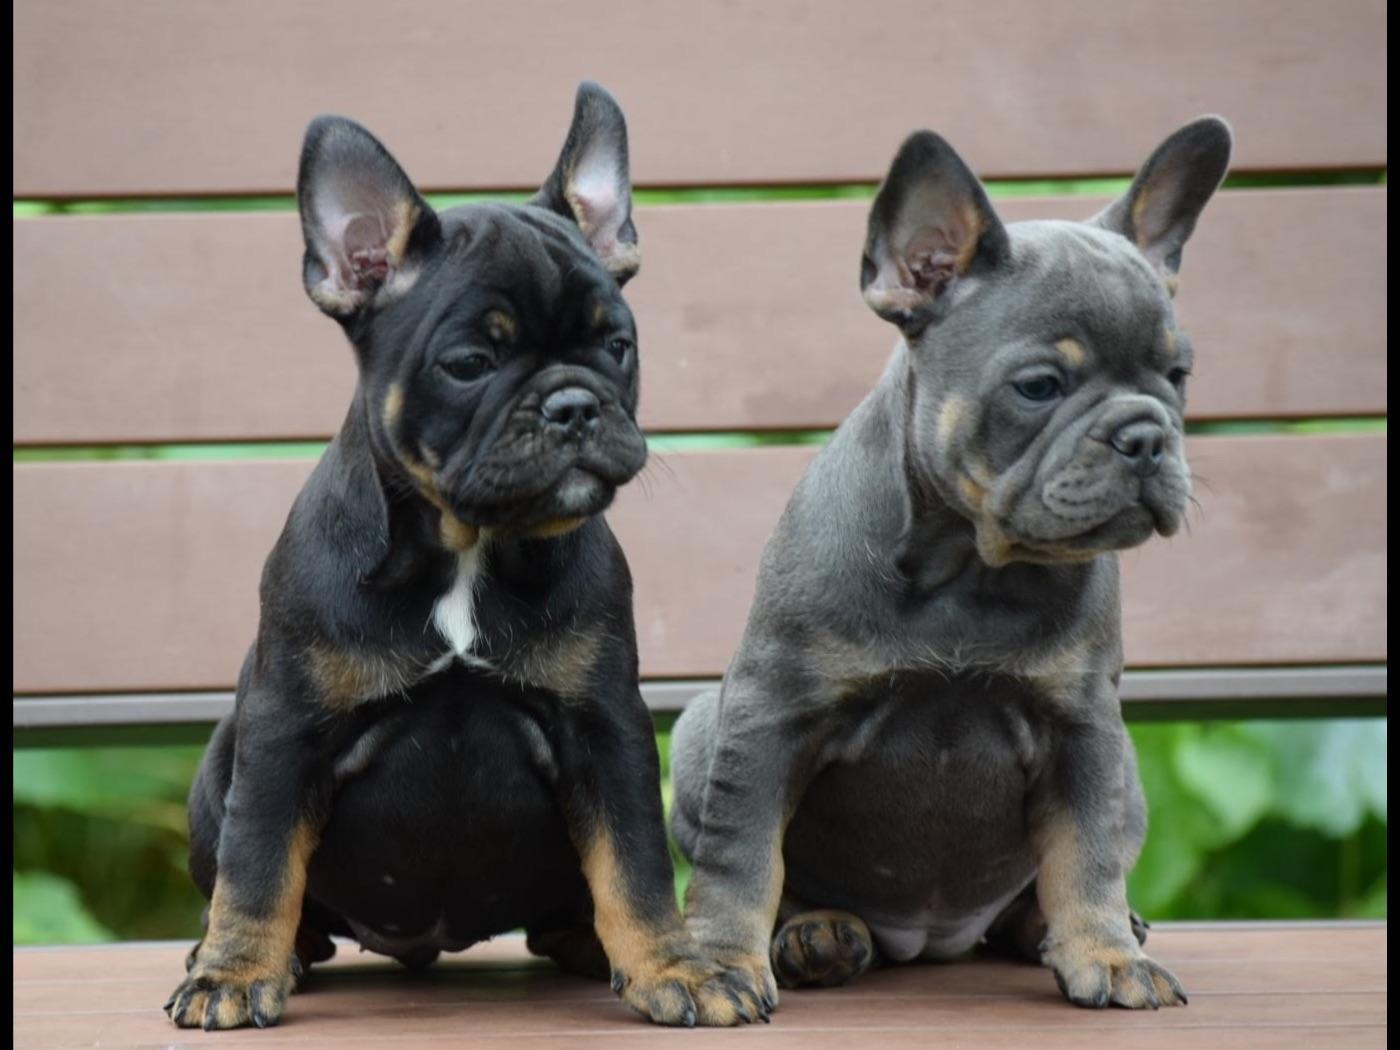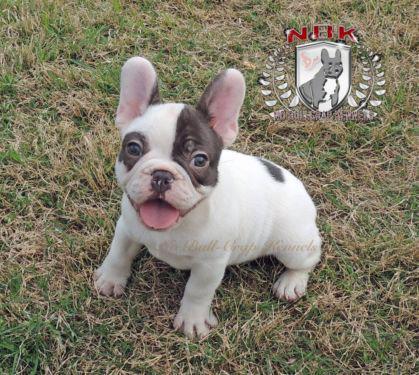The first image is the image on the left, the second image is the image on the right. Given the left and right images, does the statement "One of the images features a dog that is wearing a collar." hold true? Answer yes or no. No. The first image is the image on the left, the second image is the image on the right. Considering the images on both sides, is "One image features two french bulldogs sitting upright, and the other image features a single dog." valid? Answer yes or no. Yes. 